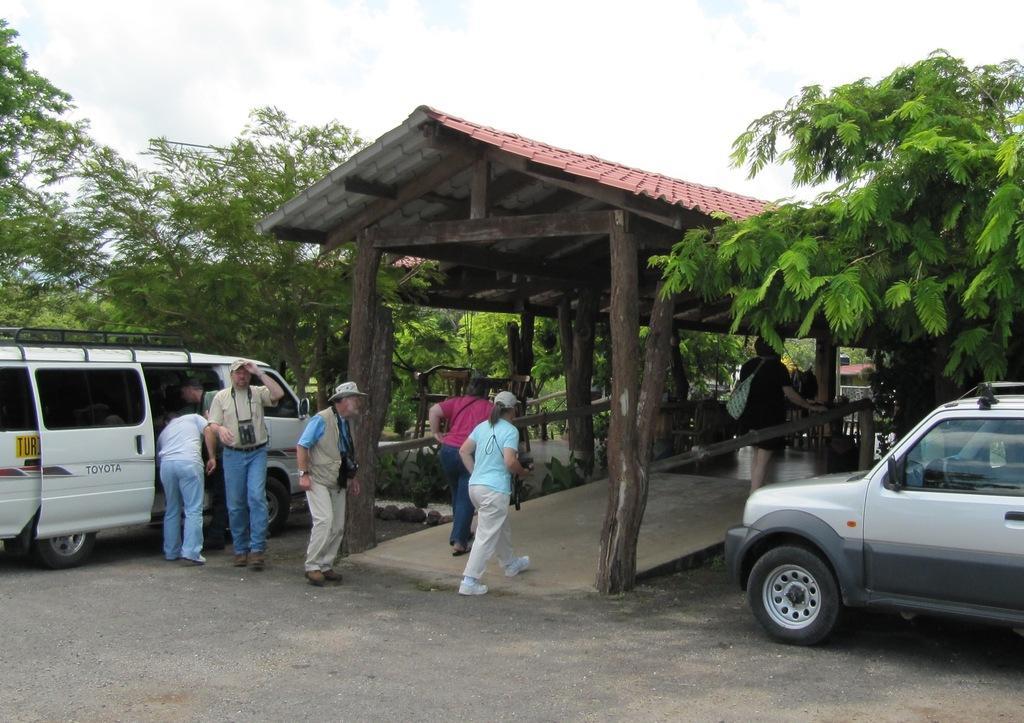In one or two sentences, can you explain what this image depicts? This image is taken outdoors. At the bottom of the image there is a road. On the left and right sides of the image there are a few trees and two cars are parked on the road. In the middle of the image a few people are walking on the sidewalk and there is a hut with roof and wooden sticks. At the top of the image there is a sky with clouds. 